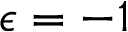Convert formula to latex. <formula><loc_0><loc_0><loc_500><loc_500>\epsilon = - 1</formula> 